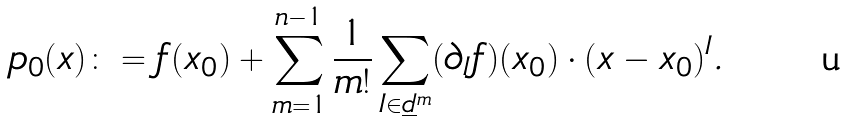Convert formula to latex. <formula><loc_0><loc_0><loc_500><loc_500>p _ { 0 } ( x ) \colon = f ( x _ { 0 } ) + \sum _ { m = 1 } ^ { n - 1 } \frac { 1 } { m ! } \sum _ { I \in \underline { d } ^ { m } } ( \partial _ { I } f ) ( x _ { 0 } ) \cdot ( x - x _ { 0 } ) ^ { I } .</formula> 